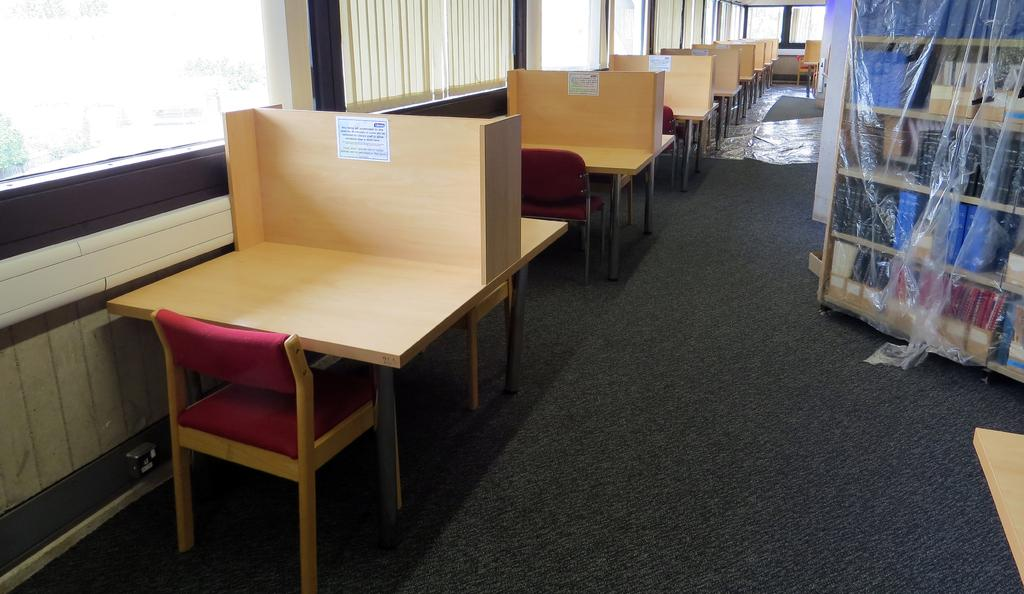What type of furniture is located in the center of the image? There are chairs and tables in the center of the image. What can be seen through the windows in the image? The image does not show what can be seen through the windows. What type of flooring is present at the bottom of the image? There is a carpet at the bottom of the image. Where are the books located in the image? The books are in a shelf on the right side of the image. What type of toy is being played with on the carpet in the image? There is no toy or play activity depicted in the image; it only shows chairs, tables, windows, a carpet, and books on a shelf. 